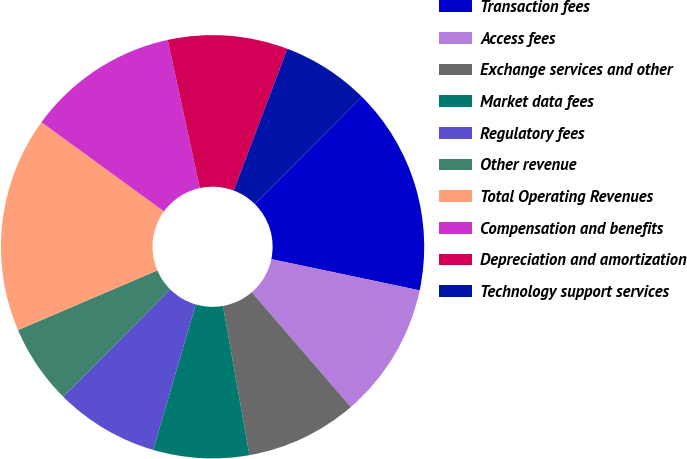Convert chart. <chart><loc_0><loc_0><loc_500><loc_500><pie_chart><fcel>Transaction fees<fcel>Access fees<fcel>Exchange services and other<fcel>Market data fees<fcel>Regulatory fees<fcel>Other revenue<fcel>Total Operating Revenues<fcel>Compensation and benefits<fcel>Depreciation and amortization<fcel>Technology support services<nl><fcel>15.85%<fcel>10.37%<fcel>8.54%<fcel>7.32%<fcel>7.93%<fcel>6.1%<fcel>16.46%<fcel>11.59%<fcel>9.15%<fcel>6.71%<nl></chart> 